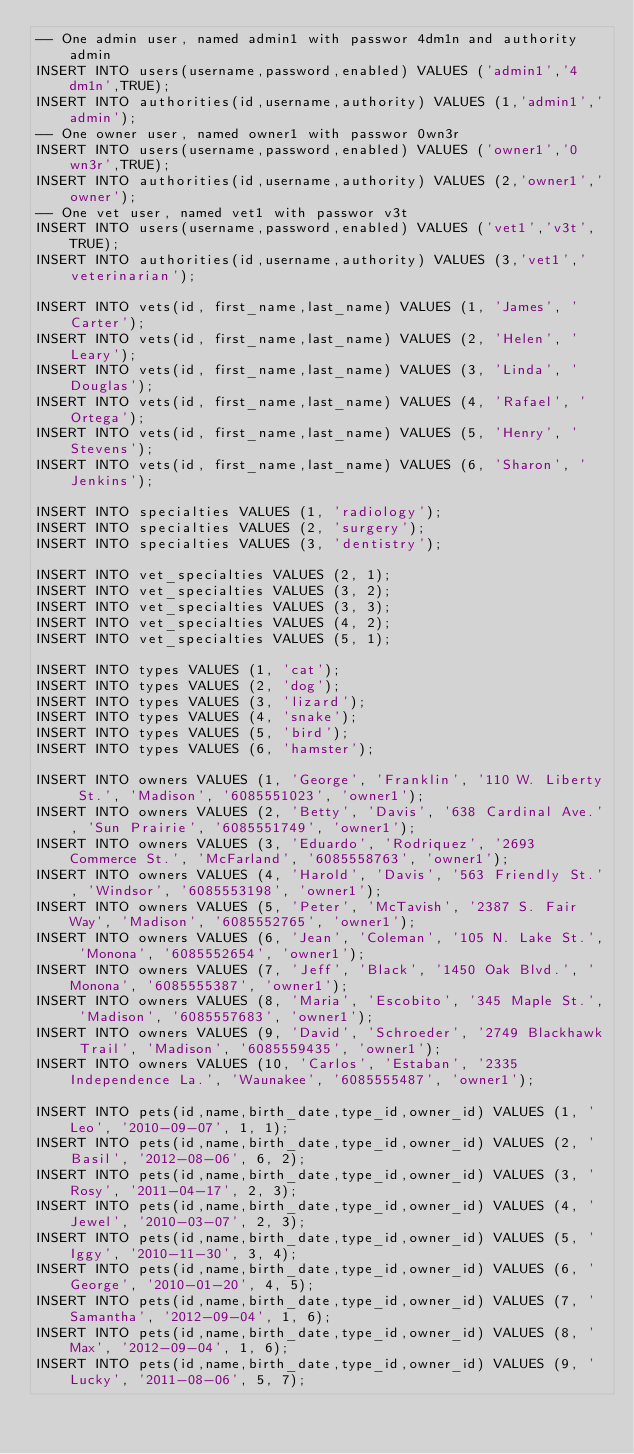Convert code to text. <code><loc_0><loc_0><loc_500><loc_500><_SQL_>-- One admin user, named admin1 with passwor 4dm1n and authority admin
INSERT INTO users(username,password,enabled) VALUES ('admin1','4dm1n',TRUE);
INSERT INTO authorities(id,username,authority) VALUES (1,'admin1','admin');
-- One owner user, named owner1 with passwor 0wn3r
INSERT INTO users(username,password,enabled) VALUES ('owner1','0wn3r',TRUE);
INSERT INTO authorities(id,username,authority) VALUES (2,'owner1','owner');
-- One vet user, named vet1 with passwor v3t
INSERT INTO users(username,password,enabled) VALUES ('vet1','v3t',TRUE);
INSERT INTO authorities(id,username,authority) VALUES (3,'vet1','veterinarian');

INSERT INTO vets(id, first_name,last_name) VALUES (1, 'James', 'Carter');
INSERT INTO vets(id, first_name,last_name) VALUES (2, 'Helen', 'Leary');
INSERT INTO vets(id, first_name,last_name) VALUES (3, 'Linda', 'Douglas');
INSERT INTO vets(id, first_name,last_name) VALUES (4, 'Rafael', 'Ortega');
INSERT INTO vets(id, first_name,last_name) VALUES (5, 'Henry', 'Stevens');
INSERT INTO vets(id, first_name,last_name) VALUES (6, 'Sharon', 'Jenkins');

INSERT INTO specialties VALUES (1, 'radiology');
INSERT INTO specialties VALUES (2, 'surgery');
INSERT INTO specialties VALUES (3, 'dentistry');

INSERT INTO vet_specialties VALUES (2, 1);
INSERT INTO vet_specialties VALUES (3, 2);
INSERT INTO vet_specialties VALUES (3, 3);
INSERT INTO vet_specialties VALUES (4, 2);
INSERT INTO vet_specialties VALUES (5, 1);

INSERT INTO types VALUES (1, 'cat');
INSERT INTO types VALUES (2, 'dog');
INSERT INTO types VALUES (3, 'lizard');
INSERT INTO types VALUES (4, 'snake');
INSERT INTO types VALUES (5, 'bird');
INSERT INTO types VALUES (6, 'hamster');

INSERT INTO owners VALUES (1, 'George', 'Franklin', '110 W. Liberty St.', 'Madison', '6085551023', 'owner1');
INSERT INTO owners VALUES (2, 'Betty', 'Davis', '638 Cardinal Ave.', 'Sun Prairie', '6085551749', 'owner1');
INSERT INTO owners VALUES (3, 'Eduardo', 'Rodriquez', '2693 Commerce St.', 'McFarland', '6085558763', 'owner1');
INSERT INTO owners VALUES (4, 'Harold', 'Davis', '563 Friendly St.', 'Windsor', '6085553198', 'owner1');
INSERT INTO owners VALUES (5, 'Peter', 'McTavish', '2387 S. Fair Way', 'Madison', '6085552765', 'owner1');
INSERT INTO owners VALUES (6, 'Jean', 'Coleman', '105 N. Lake St.', 'Monona', '6085552654', 'owner1');
INSERT INTO owners VALUES (7, 'Jeff', 'Black', '1450 Oak Blvd.', 'Monona', '6085555387', 'owner1');
INSERT INTO owners VALUES (8, 'Maria', 'Escobito', '345 Maple St.', 'Madison', '6085557683', 'owner1');
INSERT INTO owners VALUES (9, 'David', 'Schroeder', '2749 Blackhawk Trail', 'Madison', '6085559435', 'owner1');
INSERT INTO owners VALUES (10, 'Carlos', 'Estaban', '2335 Independence La.', 'Waunakee', '6085555487', 'owner1');

INSERT INTO pets(id,name,birth_date,type_id,owner_id) VALUES (1, 'Leo', '2010-09-07', 1, 1);
INSERT INTO pets(id,name,birth_date,type_id,owner_id) VALUES (2, 'Basil', '2012-08-06', 6, 2);
INSERT INTO pets(id,name,birth_date,type_id,owner_id) VALUES (3, 'Rosy', '2011-04-17', 2, 3);
INSERT INTO pets(id,name,birth_date,type_id,owner_id) VALUES (4, 'Jewel', '2010-03-07', 2, 3);
INSERT INTO pets(id,name,birth_date,type_id,owner_id) VALUES (5, 'Iggy', '2010-11-30', 3, 4);
INSERT INTO pets(id,name,birth_date,type_id,owner_id) VALUES (6, 'George', '2010-01-20', 4, 5);
INSERT INTO pets(id,name,birth_date,type_id,owner_id) VALUES (7, 'Samantha', '2012-09-04', 1, 6);
INSERT INTO pets(id,name,birth_date,type_id,owner_id) VALUES (8, 'Max', '2012-09-04', 1, 6);
INSERT INTO pets(id,name,birth_date,type_id,owner_id) VALUES (9, 'Lucky', '2011-08-06', 5, 7);</code> 